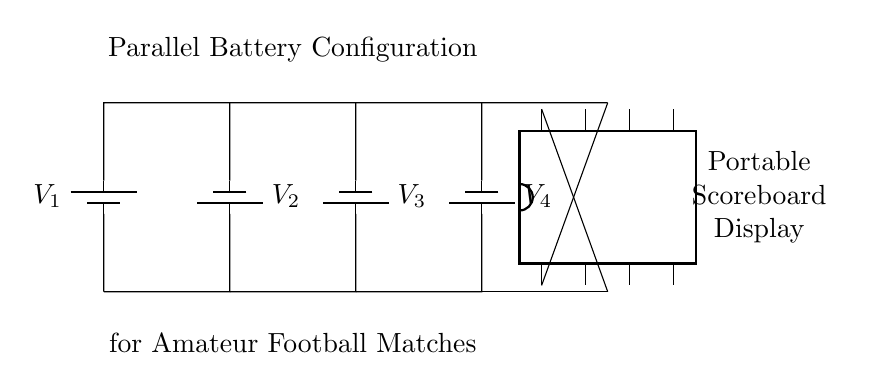What is the total number of batteries in this configuration? The circuit diagram shows four batteries connected in parallel. Each is clearly labeled, and they are all connected between the same two nodes. Hence, we count them directly from the diagram.
Answer: four What is the orientation of the batteries? Each battery is drawn vertically in the circuit diagram, with their terminals facing up and down. This orientation is consistent throughout the diagram.
Answer: vertical What is the purpose of the portable scoreboard display? The display is used to show the score during amateur football matches, as indicated by the text in the diagram that names it explicitly.
Answer: score display Are the batteries connected in series or parallel? The batteries are arranged in parallel because they share the same positive and negative connections at the respective top and bottom, allowing them to maintain the same voltage while increasing capacity.
Answer: parallel What is the likely voltage supplied by each battery? Based on typical battery specifications for portable applications, it's common to use batteries with a nominal voltage of 1.5 volts each. This assumption leads us to conclude that each battery supplies 1.5 volts.
Answer: 1.5 volts If each battery has a capacity of 2000 milliamp-hours, what is the total capacity of this configuration? Since the batteries are in parallel, the total capacity is the sum of all individual batteries' capacities. For four batteries each rated at 2000 milliamp-hours, the total capacity is 2000 times 4, which equals 8000 milliamp-hours. Proper multiplication confirms this.
Answer: 8000 milliamp-hours 